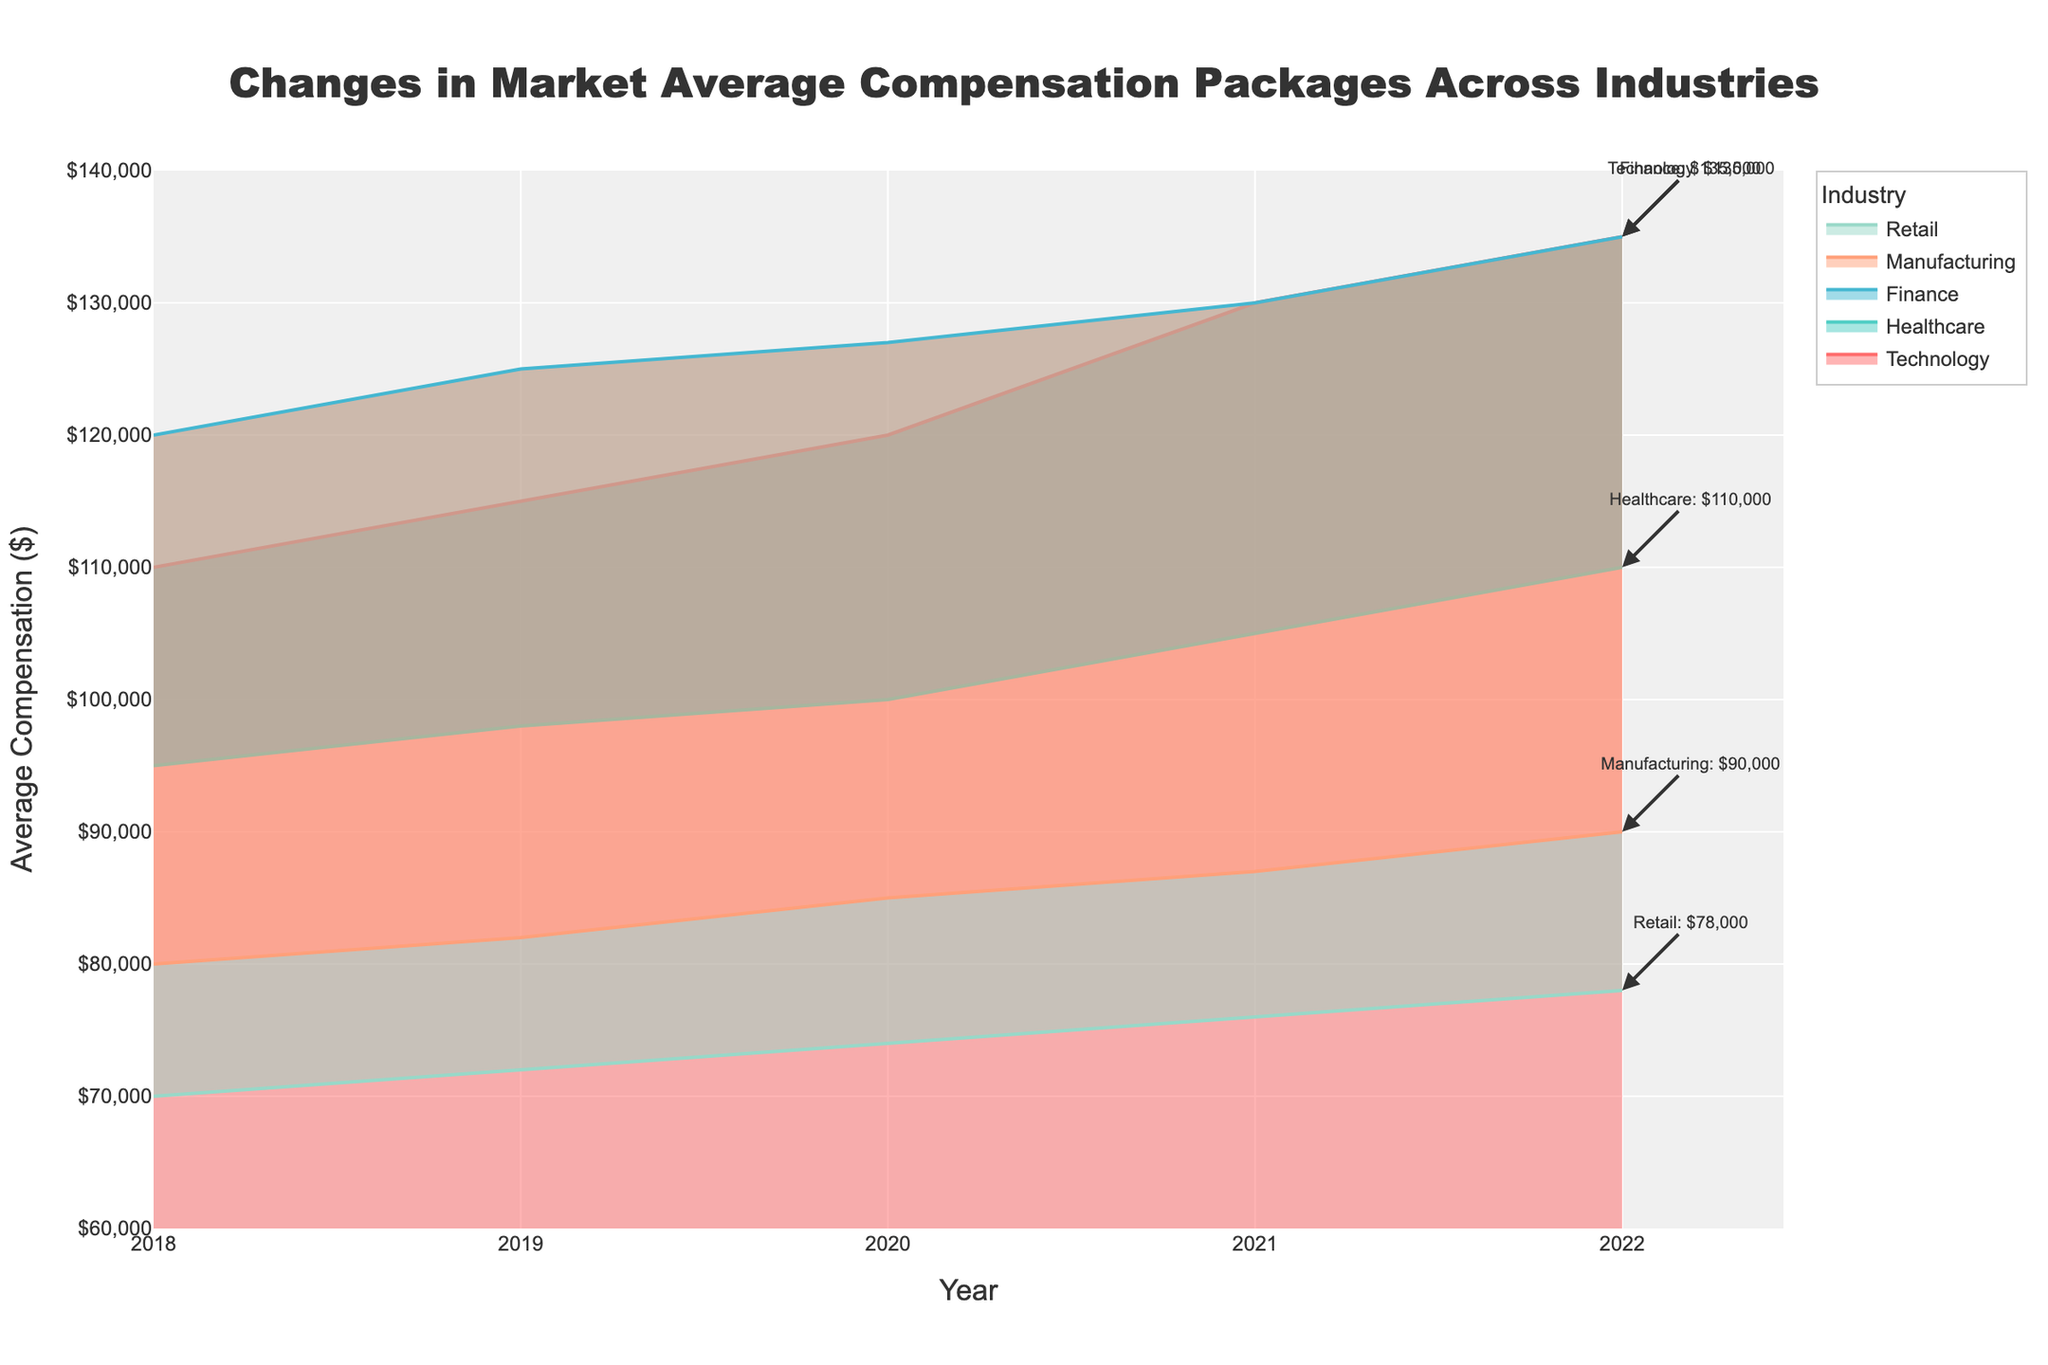what is the title of the plot? The title is displayed at the top of the figure and provides a summary of what the chart illustrates.
Answer: Changes in Market Average Compensation Packages Across Industries What is the average compensation for Manufacturing in 2020? Find the point where Manufacturing intersects with 2020 and read the corresponding value on the y-axis.
Answer: 85000 Which industry had the highest average compensation in 2019? Examine the data points for all industries in 2019 and identify the highest value on the y-axis.
Answer: Finance By how much did Technology’s average compensation increase from 2018 to 2022? Subtract the 2018 value from the 2022 value for the Technology industry.
Answer: 25000 What is the trend observed in Retail's average compensation from 2018 to 2022? Observe the area chart for Retail and see the direction in which the line moves from 2018 to 2022.
Answer: Increasing How does Healthcare's average compensation in 2021 compare to Technology’s in the same year? Identify and compare the points for Healthcare and Technology in 2021 on the y-axis.
Answer: Technology is higher Which industry shows the least growth in average compensation between 2018 and 2022? Calculate the difference between 2022 and 2018 for each industry and identify the smallest difference.
Answer: Retail What is the y-axis title and its unit of measurement? The y-axis title is displayed along the vertical axis and indicates what is being measured and the unit.
Answer: Average Compensation ($) How many industries are represented in the chart? Count the number of unique industry names denoted by different colored lines in the figure.
Answer: 5 Which industry had a steady upward trend in average compensation with no drops from 2018 to 2022? Analyze each industry's line for any declines across the years; the one with a consistent rise has no drops.
Answer: Healthcare 